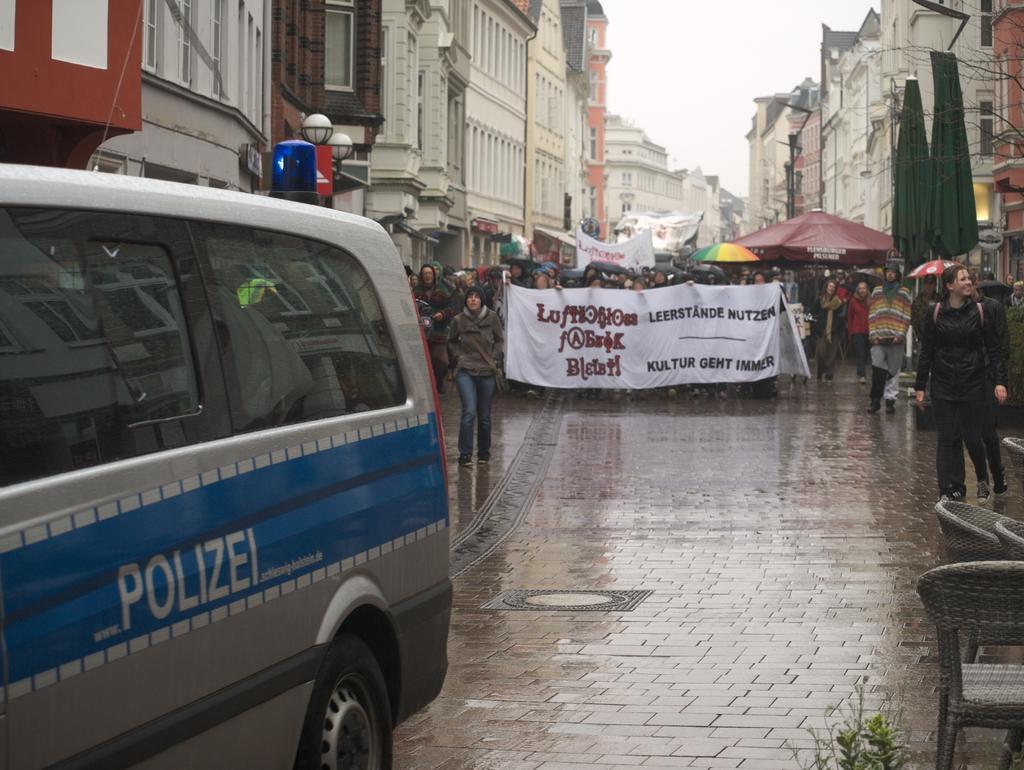Please provide a concise description of this image. In the center of the image there are people walking on road. To the left side of the image there is van. In the background of the image there are buildings. In the right side of the image there is a chair. 